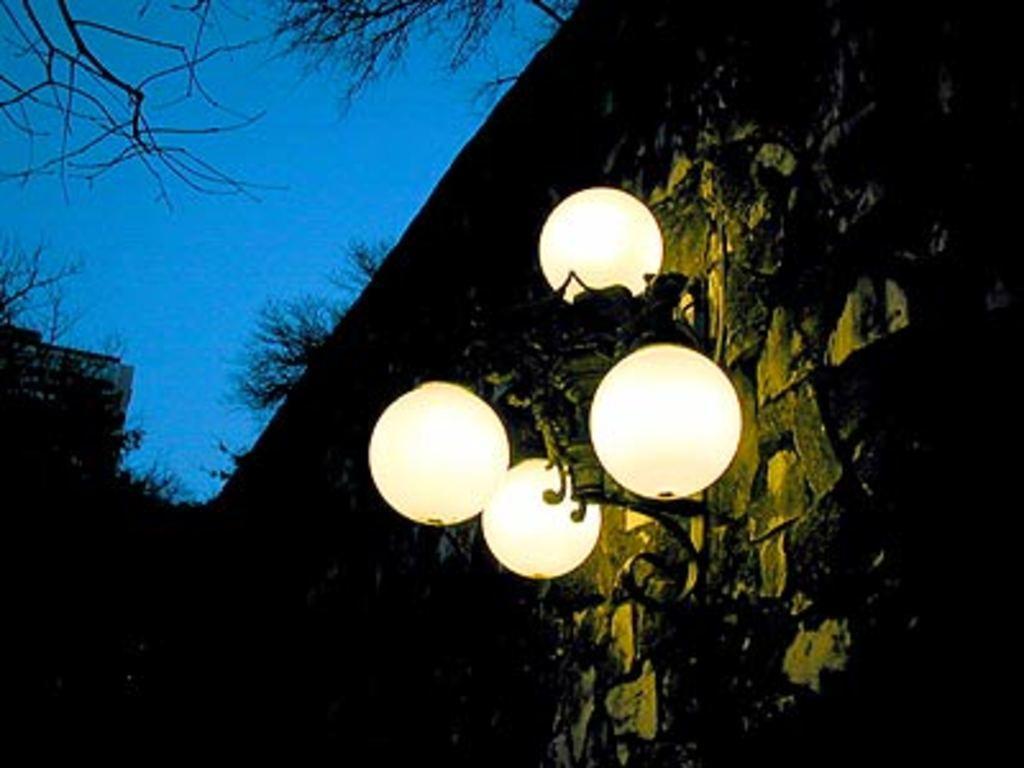How would you summarize this image in a sentence or two? In this image we can see few lamps. There is a building in the image. There are many trees in the image. We can see the sky in the image. 